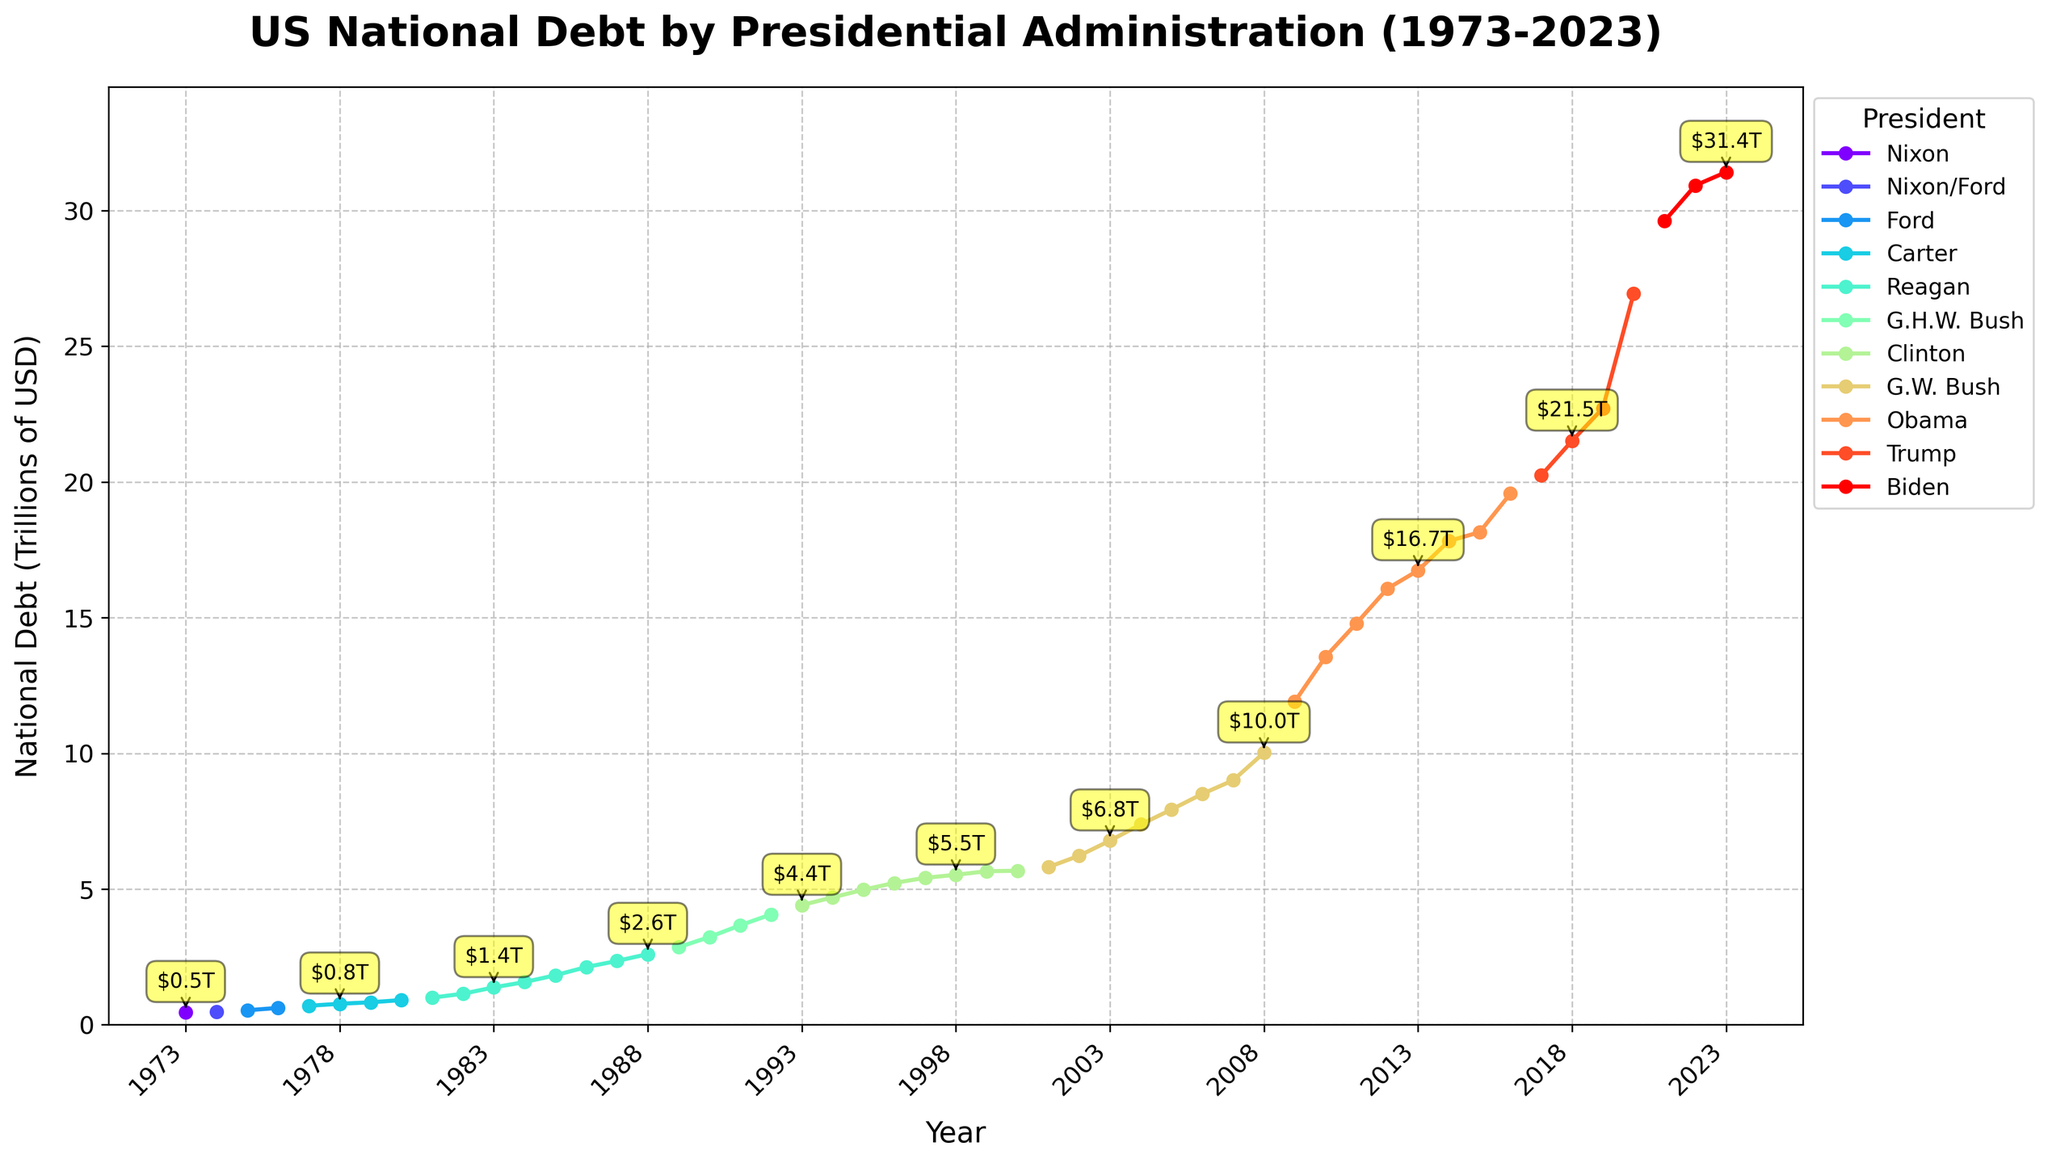What is the total increase in national debt from the beginning to the end of Reagan's presidency? First, locate the national debt for the year Reagan started (1981) and the year he ended (1988). The debt increased from $0.998 trillion in 1981 to $2.602 trillion in 1988. Then, calculate the difference: $2.602 trillion - $0.998 trillion.
Answer: $1.604 trillion Which president saw the highest single-year increase in national debt? To find this, look for the steepest upward movement between any two consecutive years on the chart. The highest increase occurs during the Trump administration between 2019 and 2020, where the debt rose from $22.719 trillion to $26.945 trillion.
Answer: Trump Compare the national debt at the end of Carter's presidency to the beginning of Reagan's presidency. Are they the same or different? At the end of Carter's presidency (1980), the national debt was $0.908 trillion. At the beginning of Reagan's presidency (1981), the national debt was $0.998 trillion. Subtract to find the difference: $0.998 trillion - $0.908 trillion.
Answer: Different By how much did the national debt increase during the Obama administration? Locate the national debt for the years Obama started (2009) and ended (2016). It increased from $11.910 trillion in 2009 to $19.573 trillion in 2016. Calculate the difference: $19.573 trillion - $11.910 trillion.
Answer: $7.663 trillion Which president experienced the slowest increase in national debt as observed from the slope of the line? Identify the line segments with the least steep upward slope, indicating the slowest increase. Clinton’s second term (1997-2000) shows the least steep slope, indicating the slowest increase.
Answer: Clinton What was the average national debt during the two terms of George W. Bush's presidency? List the national debt values from 2001 to 2008 and calculate the average: (5.807 + 6.228 + 6.783 + 7.379 + 7.933 + 8.507 + 9.008 + 10.025) / 8. Sum the values and divide by 8.
Answer: $7.458 trillion How did the national debt change during the transition between Nixon/Ford and Ford? Identify the national debt in 1974 (Nixon/Ford) and 1975 (Ford). The debt increased from $0.475 trillion in 1974 to $0.533 trillion in 1975. Calculate the difference: $0.533 trillion - $0.475 trillion.
Answer: $0.058 trillion Which president had the highest ending national debt at the end of their term? Identify the final national debt for each president's last year in office. Biden had the highest ending national debt in 2023 with $31.419 trillion.
Answer: Biden Is the increase in national debt more significant during Republican or Democratic administrations on average? Sum the total increases for Republican presidents (Nixon/Ford, Reagan, G.H.W. Bush, G.W. Bush, Trump) and Democratic presidents (Carter, Clinton, Obama, Biden), then average them. Compare the two averages.
Answer: Republican administrations show a more significant average increase 